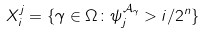<formula> <loc_0><loc_0><loc_500><loc_500>X ^ { j } _ { i } = \{ \gamma \in \Omega \colon \psi _ { j } ^ { \mathcal { A } _ { \gamma } } > i / 2 ^ { n } \}</formula> 